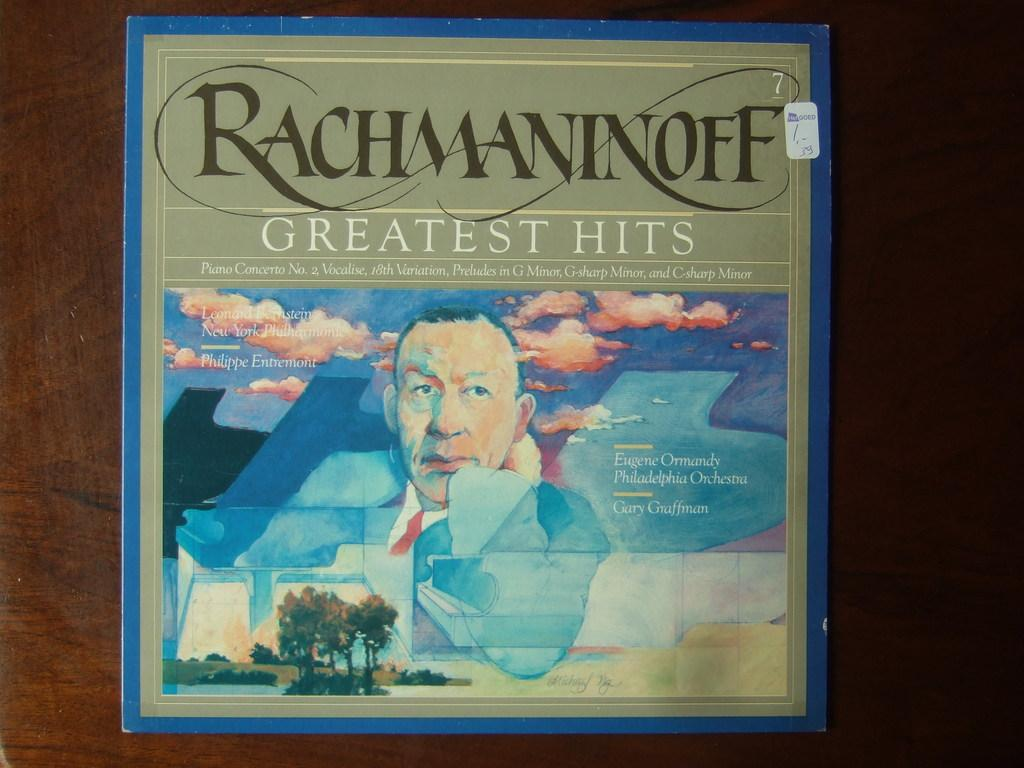<image>
Share a concise interpretation of the image provided. An album of Rachmaninoff greatest hits has am image of a man in a red tie on the cover. 